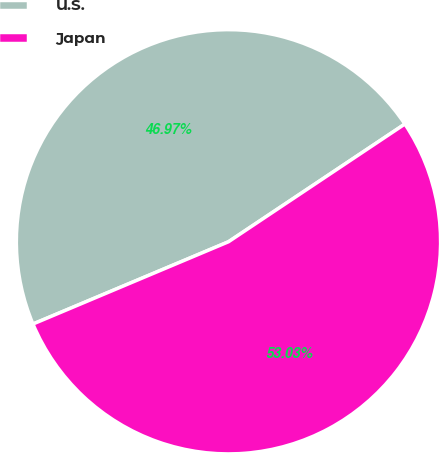Convert chart to OTSL. <chart><loc_0><loc_0><loc_500><loc_500><pie_chart><fcel>U.S.<fcel>Japan<nl><fcel>46.97%<fcel>53.03%<nl></chart> 